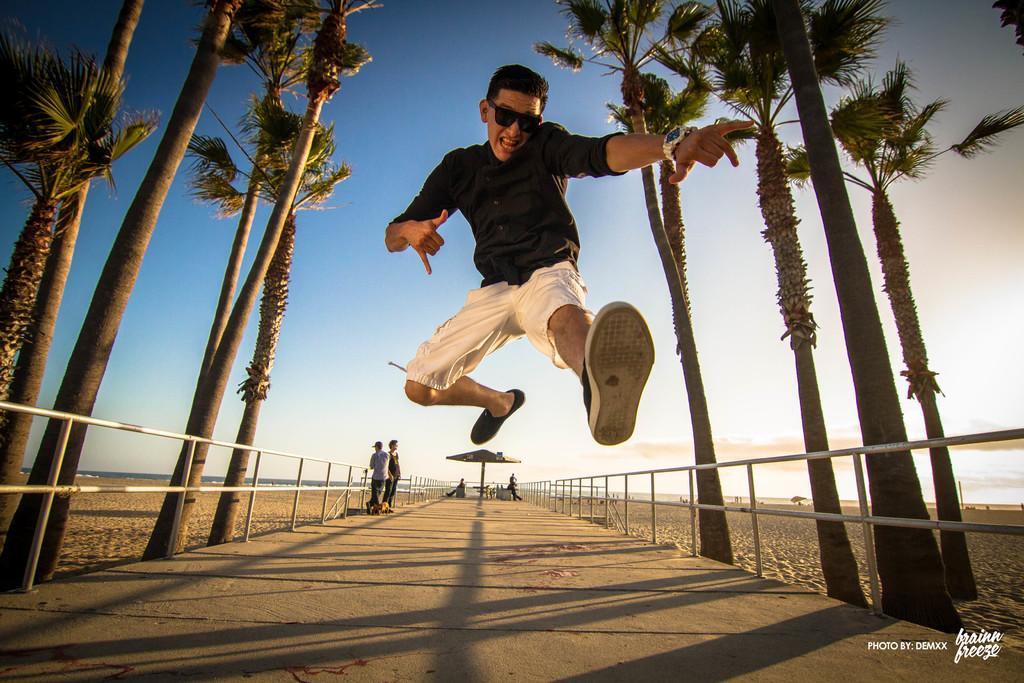Can you describe this image briefly? In the foreground of this image, there is a man in the air. On the bottom, there is the path. On either side, there is railing and trees. In the background there are persons, an umbrella, sand and the sky. 